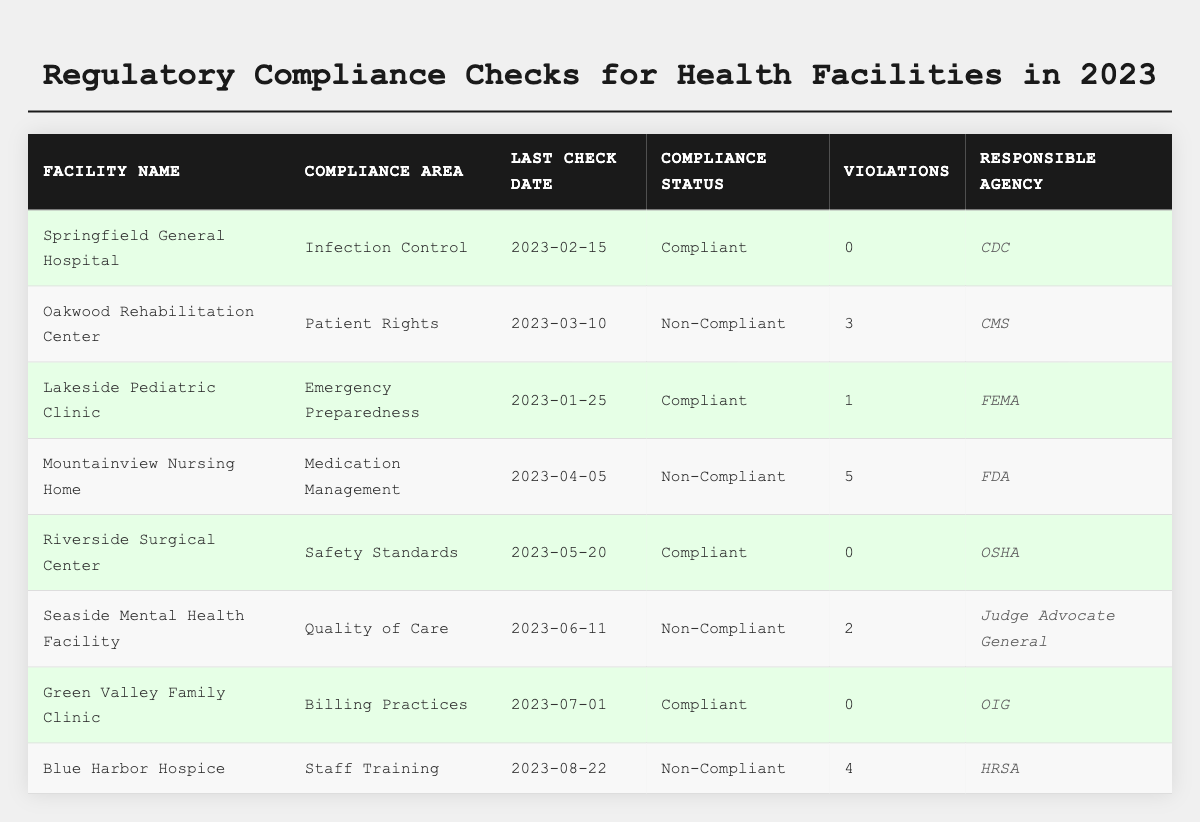What is the compliance status of Springfield General Hospital? According to the table, Springfield General Hospital has a compliance status of "Compliant".
Answer: Compliant How many violations were found at Mountainview Nursing Home? The table indicates that Mountainview Nursing Home had 5 violations during the last compliance check.
Answer: 5 Which facility had the last check date on March 10, 2023? Referring to the table, Oakwood Rehabilitation Center had its last check date on March 10, 2023.
Answer: Oakwood Rehabilitation Center What is the total number of violations from all non-compliant facilities? Summing the violations from non-compliant facilities: 3 (Oakwood Rehabilitation Center) + 5 (Mountainview Nursing Home) + 2 (Seaside Mental Health Facility) + 4 (Blue Harbor Hospice) = 14.
Answer: 14 Is Green Valley Family Clinic compliant or non-compliant? The table shows that Green Valley Family Clinic is "Compliant".
Answer: Compliant What is the most common compliance area for non-compliant facilities? The non-compliant facilities focus on: Patient Rights, Medication Management, Quality of Care, and Staff Training. Each area is unique, indicating no common area among the non-compliant facilities.
Answer: None Which agency is responsible for the compliance check of Lakeside Pediatric Clinic? The table specifies that FEMA is the responsible agency for the compliance check of Lakeside Pediatric Clinic.
Answer: FEMA How many facilities have a compliance status of 'Compliant'? Counting the 'Compliant' facilities in the table: Springfield General Hospital, Lakeside Pediatric Clinic, Riverside Surgical Center, and Green Valley Family Clinic makes 4 facilities in total.
Answer: 4 Which two agencies are responsible for the checks of the non-compliant facilities with the highest violations? The non-compliant facility with the highest violations is Mountainview Nursing Home (5) under FDA, followed by Blue Harbor Hospice (4) under HRSA. These are the agencies responsible for the highest violations.
Answer: FDA, HRSA 